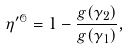<formula> <loc_0><loc_0><loc_500><loc_500>\eta ^ { \prime \mathcal { O } } = 1 - \frac { g ( \gamma _ { 2 } ) } { g ( \gamma _ { 1 } ) } ,</formula> 